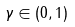<formula> <loc_0><loc_0><loc_500><loc_500>\gamma \in ( 0 , 1 )</formula> 